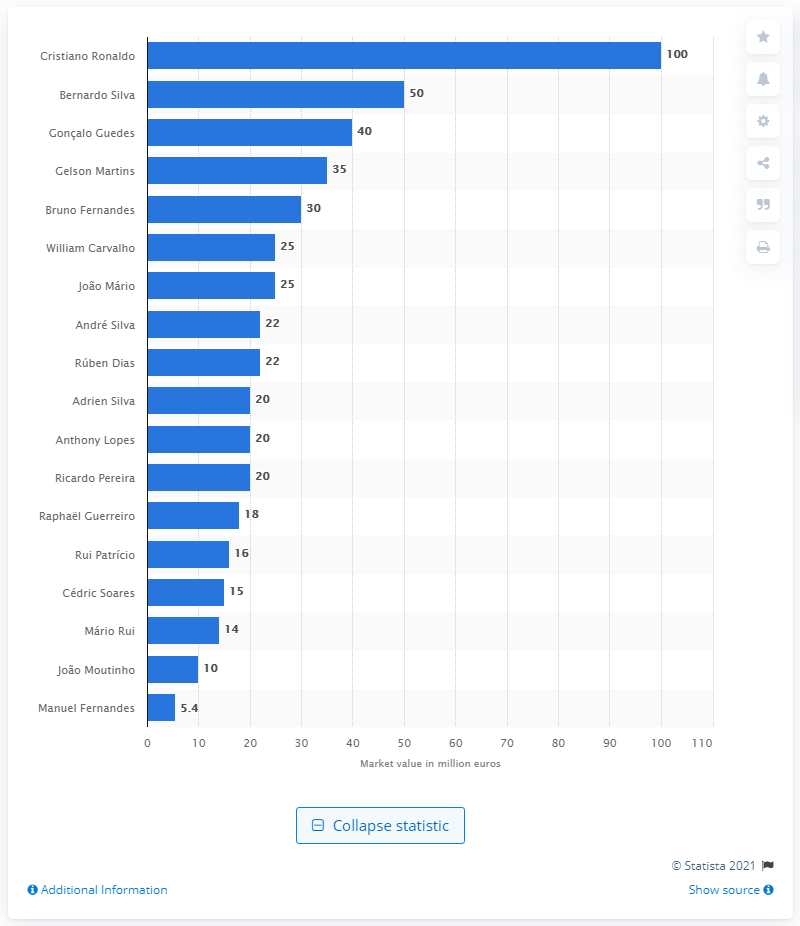Highlight a few significant elements in this photo. The most valuable player at the 2018 FIFA World Cup was Cristiano Ronaldo. Cristiano Ronaldo's market value was 100 million dollars. 